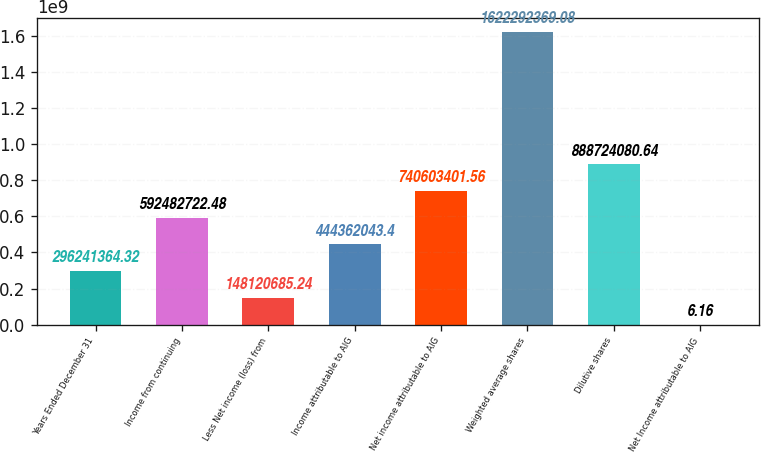Convert chart to OTSL. <chart><loc_0><loc_0><loc_500><loc_500><bar_chart><fcel>Years Ended December 31<fcel>Income from continuing<fcel>Less Net income (loss) from<fcel>Income attributable to AIG<fcel>Net income attributable to AIG<fcel>Weighted average shares<fcel>Dilutive shares<fcel>Net Income attributable to AIG<nl><fcel>2.96241e+08<fcel>5.92483e+08<fcel>1.48121e+08<fcel>4.44362e+08<fcel>7.40603e+08<fcel>1.62229e+09<fcel>8.88724e+08<fcel>6.16<nl></chart> 